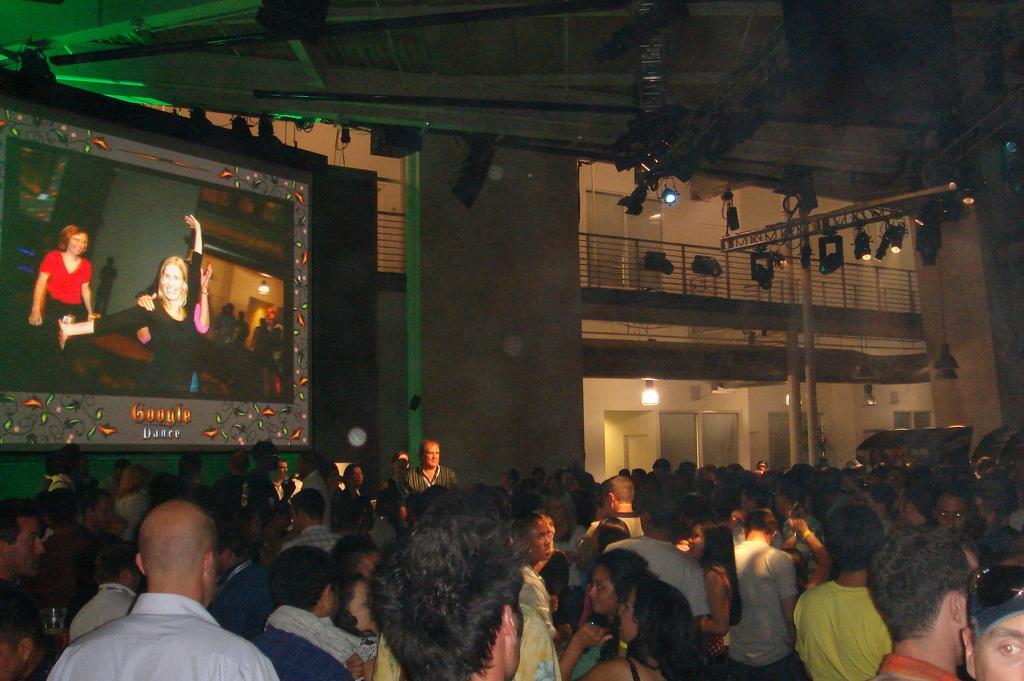Could you give a brief overview of what you see in this image? At the bottom of the picture, we see the people are standing. On the left side, we see the monitor screen which is displaying the people who are standing. In front of the screen, we see a woman is smiling and she might be dancing. On the right side, we see a pillar and beside that, we see a pole and the lights. In the background, we see a building, a pillar, doors and the lights. At the top, we see the roof of the building. 